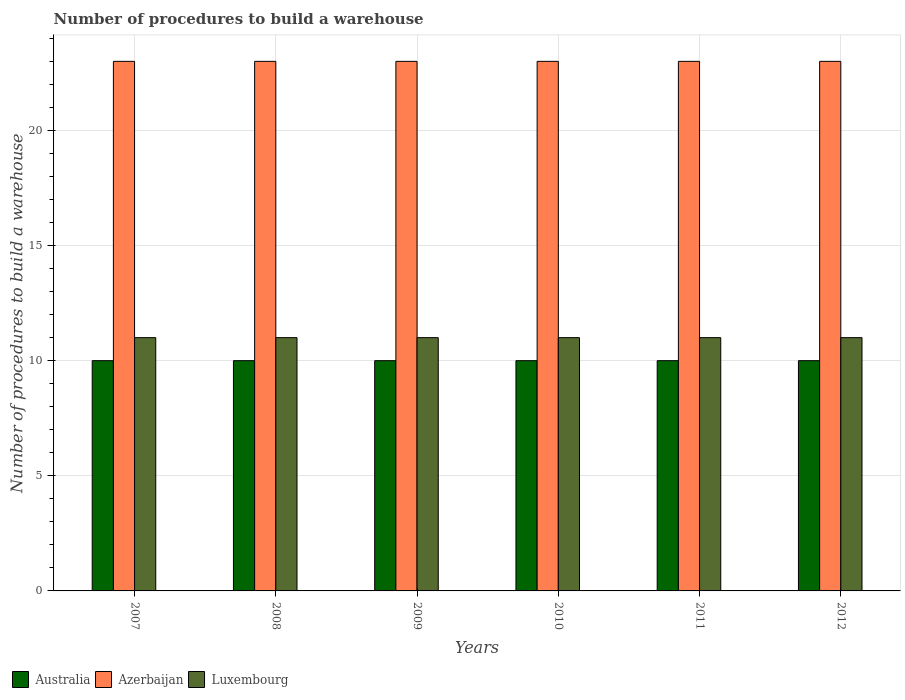How many bars are there on the 1st tick from the left?
Provide a short and direct response. 3. Across all years, what is the maximum number of procedures to build a warehouse in in Australia?
Give a very brief answer. 10. Across all years, what is the minimum number of procedures to build a warehouse in in Australia?
Offer a terse response. 10. What is the total number of procedures to build a warehouse in in Australia in the graph?
Your answer should be very brief. 60. What is the difference between the number of procedures to build a warehouse in in Azerbaijan in 2007 and the number of procedures to build a warehouse in in Luxembourg in 2010?
Keep it short and to the point. 12. What is the average number of procedures to build a warehouse in in Luxembourg per year?
Provide a short and direct response. 11. What is the ratio of the number of procedures to build a warehouse in in Luxembourg in 2008 to that in 2010?
Provide a succinct answer. 1. Is the number of procedures to build a warehouse in in Luxembourg in 2007 less than that in 2008?
Provide a succinct answer. No. What is the difference between the highest and the second highest number of procedures to build a warehouse in in Australia?
Keep it short and to the point. 0. In how many years, is the number of procedures to build a warehouse in in Australia greater than the average number of procedures to build a warehouse in in Australia taken over all years?
Offer a very short reply. 0. What does the 1st bar from the left in 2010 represents?
Offer a terse response. Australia. What does the 1st bar from the right in 2010 represents?
Ensure brevity in your answer.  Luxembourg. Are the values on the major ticks of Y-axis written in scientific E-notation?
Make the answer very short. No. Does the graph contain grids?
Provide a short and direct response. Yes. How many legend labels are there?
Offer a terse response. 3. How are the legend labels stacked?
Your response must be concise. Horizontal. What is the title of the graph?
Your answer should be very brief. Number of procedures to build a warehouse. What is the label or title of the Y-axis?
Give a very brief answer. Number of procedures to build a warehouse. What is the Number of procedures to build a warehouse in Luxembourg in 2007?
Offer a terse response. 11. What is the Number of procedures to build a warehouse of Australia in 2008?
Offer a very short reply. 10. What is the Number of procedures to build a warehouse in Luxembourg in 2009?
Keep it short and to the point. 11. What is the Number of procedures to build a warehouse of Australia in 2011?
Give a very brief answer. 10. What is the Number of procedures to build a warehouse in Azerbaijan in 2011?
Keep it short and to the point. 23. What is the Number of procedures to build a warehouse in Luxembourg in 2011?
Keep it short and to the point. 11. What is the Number of procedures to build a warehouse in Australia in 2012?
Keep it short and to the point. 10. What is the Number of procedures to build a warehouse in Luxembourg in 2012?
Provide a short and direct response. 11. Across all years, what is the minimum Number of procedures to build a warehouse in Australia?
Keep it short and to the point. 10. Across all years, what is the minimum Number of procedures to build a warehouse of Azerbaijan?
Your answer should be very brief. 23. Across all years, what is the minimum Number of procedures to build a warehouse in Luxembourg?
Ensure brevity in your answer.  11. What is the total Number of procedures to build a warehouse of Australia in the graph?
Provide a succinct answer. 60. What is the total Number of procedures to build a warehouse of Azerbaijan in the graph?
Your answer should be compact. 138. What is the difference between the Number of procedures to build a warehouse in Azerbaijan in 2007 and that in 2008?
Provide a succinct answer. 0. What is the difference between the Number of procedures to build a warehouse in Australia in 2007 and that in 2009?
Give a very brief answer. 0. What is the difference between the Number of procedures to build a warehouse in Luxembourg in 2007 and that in 2010?
Your answer should be very brief. 0. What is the difference between the Number of procedures to build a warehouse in Australia in 2007 and that in 2011?
Your response must be concise. 0. What is the difference between the Number of procedures to build a warehouse in Azerbaijan in 2007 and that in 2011?
Provide a short and direct response. 0. What is the difference between the Number of procedures to build a warehouse in Azerbaijan in 2007 and that in 2012?
Keep it short and to the point. 0. What is the difference between the Number of procedures to build a warehouse in Luxembourg in 2007 and that in 2012?
Offer a terse response. 0. What is the difference between the Number of procedures to build a warehouse of Azerbaijan in 2008 and that in 2009?
Give a very brief answer. 0. What is the difference between the Number of procedures to build a warehouse in Australia in 2008 and that in 2010?
Provide a short and direct response. 0. What is the difference between the Number of procedures to build a warehouse of Azerbaijan in 2008 and that in 2010?
Ensure brevity in your answer.  0. What is the difference between the Number of procedures to build a warehouse in Australia in 2008 and that in 2011?
Your response must be concise. 0. What is the difference between the Number of procedures to build a warehouse of Azerbaijan in 2009 and that in 2010?
Your response must be concise. 0. What is the difference between the Number of procedures to build a warehouse in Luxembourg in 2009 and that in 2010?
Give a very brief answer. 0. What is the difference between the Number of procedures to build a warehouse in Australia in 2009 and that in 2011?
Offer a very short reply. 0. What is the difference between the Number of procedures to build a warehouse in Luxembourg in 2009 and that in 2011?
Your response must be concise. 0. What is the difference between the Number of procedures to build a warehouse of Azerbaijan in 2010 and that in 2011?
Your response must be concise. 0. What is the difference between the Number of procedures to build a warehouse in Azerbaijan in 2007 and the Number of procedures to build a warehouse in Luxembourg in 2008?
Keep it short and to the point. 12. What is the difference between the Number of procedures to build a warehouse in Australia in 2007 and the Number of procedures to build a warehouse in Azerbaijan in 2009?
Give a very brief answer. -13. What is the difference between the Number of procedures to build a warehouse of Azerbaijan in 2007 and the Number of procedures to build a warehouse of Luxembourg in 2009?
Offer a very short reply. 12. What is the difference between the Number of procedures to build a warehouse of Australia in 2007 and the Number of procedures to build a warehouse of Azerbaijan in 2010?
Provide a succinct answer. -13. What is the difference between the Number of procedures to build a warehouse of Azerbaijan in 2007 and the Number of procedures to build a warehouse of Luxembourg in 2010?
Give a very brief answer. 12. What is the difference between the Number of procedures to build a warehouse in Australia in 2007 and the Number of procedures to build a warehouse in Azerbaijan in 2011?
Provide a short and direct response. -13. What is the difference between the Number of procedures to build a warehouse of Azerbaijan in 2007 and the Number of procedures to build a warehouse of Luxembourg in 2011?
Your response must be concise. 12. What is the difference between the Number of procedures to build a warehouse of Australia in 2007 and the Number of procedures to build a warehouse of Luxembourg in 2012?
Provide a succinct answer. -1. What is the difference between the Number of procedures to build a warehouse of Australia in 2008 and the Number of procedures to build a warehouse of Azerbaijan in 2009?
Your answer should be very brief. -13. What is the difference between the Number of procedures to build a warehouse in Azerbaijan in 2008 and the Number of procedures to build a warehouse in Luxembourg in 2009?
Your answer should be very brief. 12. What is the difference between the Number of procedures to build a warehouse of Australia in 2008 and the Number of procedures to build a warehouse of Azerbaijan in 2010?
Provide a succinct answer. -13. What is the difference between the Number of procedures to build a warehouse in Azerbaijan in 2008 and the Number of procedures to build a warehouse in Luxembourg in 2010?
Provide a succinct answer. 12. What is the difference between the Number of procedures to build a warehouse of Australia in 2008 and the Number of procedures to build a warehouse of Azerbaijan in 2011?
Give a very brief answer. -13. What is the difference between the Number of procedures to build a warehouse of Australia in 2008 and the Number of procedures to build a warehouse of Luxembourg in 2011?
Offer a very short reply. -1. What is the difference between the Number of procedures to build a warehouse in Azerbaijan in 2008 and the Number of procedures to build a warehouse in Luxembourg in 2011?
Your answer should be very brief. 12. What is the difference between the Number of procedures to build a warehouse in Australia in 2008 and the Number of procedures to build a warehouse in Azerbaijan in 2012?
Your answer should be compact. -13. What is the difference between the Number of procedures to build a warehouse of Australia in 2008 and the Number of procedures to build a warehouse of Luxembourg in 2012?
Offer a very short reply. -1. What is the difference between the Number of procedures to build a warehouse in Australia in 2009 and the Number of procedures to build a warehouse in Azerbaijan in 2010?
Give a very brief answer. -13. What is the difference between the Number of procedures to build a warehouse of Australia in 2009 and the Number of procedures to build a warehouse of Luxembourg in 2010?
Provide a short and direct response. -1. What is the difference between the Number of procedures to build a warehouse of Azerbaijan in 2009 and the Number of procedures to build a warehouse of Luxembourg in 2010?
Your answer should be compact. 12. What is the difference between the Number of procedures to build a warehouse in Azerbaijan in 2009 and the Number of procedures to build a warehouse in Luxembourg in 2012?
Ensure brevity in your answer.  12. What is the difference between the Number of procedures to build a warehouse of Australia in 2010 and the Number of procedures to build a warehouse of Azerbaijan in 2011?
Your response must be concise. -13. What is the difference between the Number of procedures to build a warehouse in Australia in 2010 and the Number of procedures to build a warehouse in Luxembourg in 2011?
Give a very brief answer. -1. What is the difference between the Number of procedures to build a warehouse of Azerbaijan in 2010 and the Number of procedures to build a warehouse of Luxembourg in 2011?
Provide a succinct answer. 12. What is the difference between the Number of procedures to build a warehouse of Azerbaijan in 2010 and the Number of procedures to build a warehouse of Luxembourg in 2012?
Offer a terse response. 12. What is the difference between the Number of procedures to build a warehouse of Australia in 2011 and the Number of procedures to build a warehouse of Azerbaijan in 2012?
Make the answer very short. -13. What is the average Number of procedures to build a warehouse in Azerbaijan per year?
Your answer should be very brief. 23. What is the average Number of procedures to build a warehouse of Luxembourg per year?
Your answer should be very brief. 11. In the year 2008, what is the difference between the Number of procedures to build a warehouse of Australia and Number of procedures to build a warehouse of Azerbaijan?
Keep it short and to the point. -13. In the year 2008, what is the difference between the Number of procedures to build a warehouse in Australia and Number of procedures to build a warehouse in Luxembourg?
Provide a short and direct response. -1. In the year 2009, what is the difference between the Number of procedures to build a warehouse of Australia and Number of procedures to build a warehouse of Azerbaijan?
Provide a short and direct response. -13. In the year 2009, what is the difference between the Number of procedures to build a warehouse in Azerbaijan and Number of procedures to build a warehouse in Luxembourg?
Offer a very short reply. 12. In the year 2010, what is the difference between the Number of procedures to build a warehouse in Australia and Number of procedures to build a warehouse in Azerbaijan?
Provide a short and direct response. -13. In the year 2010, what is the difference between the Number of procedures to build a warehouse in Australia and Number of procedures to build a warehouse in Luxembourg?
Provide a succinct answer. -1. In the year 2010, what is the difference between the Number of procedures to build a warehouse of Azerbaijan and Number of procedures to build a warehouse of Luxembourg?
Your answer should be compact. 12. In the year 2011, what is the difference between the Number of procedures to build a warehouse of Australia and Number of procedures to build a warehouse of Luxembourg?
Your answer should be compact. -1. In the year 2011, what is the difference between the Number of procedures to build a warehouse in Azerbaijan and Number of procedures to build a warehouse in Luxembourg?
Offer a very short reply. 12. In the year 2012, what is the difference between the Number of procedures to build a warehouse in Australia and Number of procedures to build a warehouse in Luxembourg?
Keep it short and to the point. -1. In the year 2012, what is the difference between the Number of procedures to build a warehouse in Azerbaijan and Number of procedures to build a warehouse in Luxembourg?
Your answer should be very brief. 12. What is the ratio of the Number of procedures to build a warehouse in Luxembourg in 2007 to that in 2008?
Your response must be concise. 1. What is the ratio of the Number of procedures to build a warehouse in Luxembourg in 2007 to that in 2009?
Your response must be concise. 1. What is the ratio of the Number of procedures to build a warehouse in Azerbaijan in 2007 to that in 2010?
Offer a very short reply. 1. What is the ratio of the Number of procedures to build a warehouse in Luxembourg in 2007 to that in 2010?
Offer a very short reply. 1. What is the ratio of the Number of procedures to build a warehouse of Australia in 2007 to that in 2011?
Keep it short and to the point. 1. What is the ratio of the Number of procedures to build a warehouse in Luxembourg in 2007 to that in 2011?
Offer a very short reply. 1. What is the ratio of the Number of procedures to build a warehouse in Australia in 2007 to that in 2012?
Provide a short and direct response. 1. What is the ratio of the Number of procedures to build a warehouse in Azerbaijan in 2007 to that in 2012?
Keep it short and to the point. 1. What is the ratio of the Number of procedures to build a warehouse in Luxembourg in 2007 to that in 2012?
Your answer should be very brief. 1. What is the ratio of the Number of procedures to build a warehouse in Australia in 2008 to that in 2009?
Give a very brief answer. 1. What is the ratio of the Number of procedures to build a warehouse in Luxembourg in 2008 to that in 2009?
Give a very brief answer. 1. What is the ratio of the Number of procedures to build a warehouse in Australia in 2008 to that in 2010?
Offer a very short reply. 1. What is the ratio of the Number of procedures to build a warehouse in Azerbaijan in 2008 to that in 2010?
Make the answer very short. 1. What is the ratio of the Number of procedures to build a warehouse in Australia in 2008 to that in 2012?
Offer a very short reply. 1. What is the ratio of the Number of procedures to build a warehouse in Azerbaijan in 2008 to that in 2012?
Ensure brevity in your answer.  1. What is the ratio of the Number of procedures to build a warehouse in Luxembourg in 2009 to that in 2010?
Your response must be concise. 1. What is the ratio of the Number of procedures to build a warehouse of Australia in 2009 to that in 2011?
Offer a terse response. 1. What is the ratio of the Number of procedures to build a warehouse of Australia in 2009 to that in 2012?
Give a very brief answer. 1. What is the ratio of the Number of procedures to build a warehouse in Azerbaijan in 2009 to that in 2012?
Provide a short and direct response. 1. What is the ratio of the Number of procedures to build a warehouse in Luxembourg in 2009 to that in 2012?
Your answer should be very brief. 1. What is the ratio of the Number of procedures to build a warehouse of Luxembourg in 2010 to that in 2011?
Provide a short and direct response. 1. What is the ratio of the Number of procedures to build a warehouse in Australia in 2011 to that in 2012?
Your answer should be compact. 1. What is the ratio of the Number of procedures to build a warehouse in Azerbaijan in 2011 to that in 2012?
Your response must be concise. 1. What is the ratio of the Number of procedures to build a warehouse of Luxembourg in 2011 to that in 2012?
Ensure brevity in your answer.  1. What is the difference between the highest and the lowest Number of procedures to build a warehouse of Azerbaijan?
Make the answer very short. 0. 